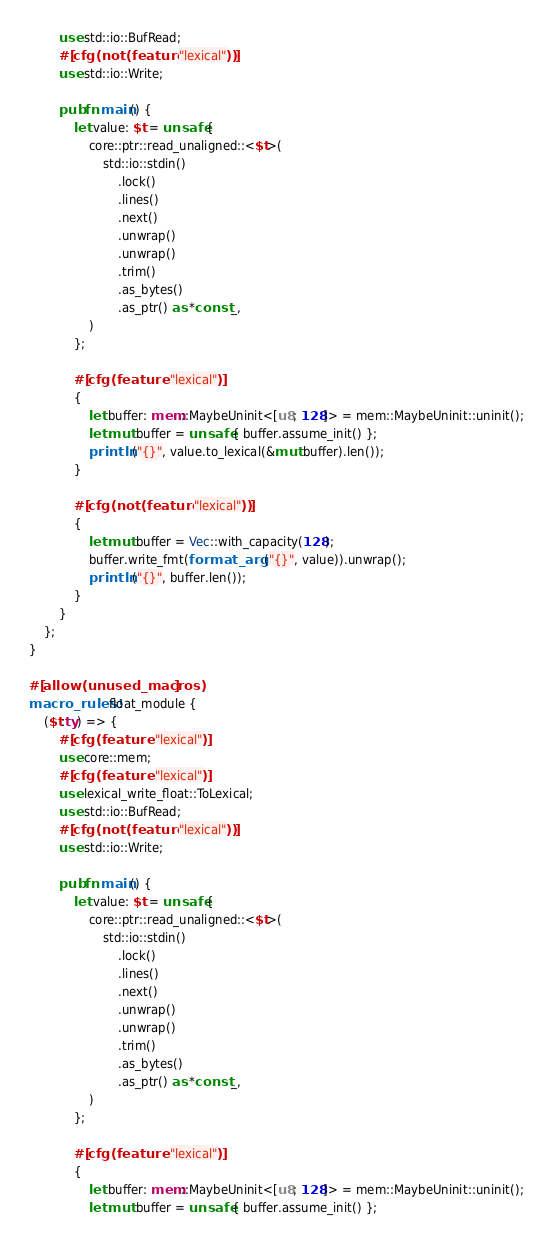Convert code to text. <code><loc_0><loc_0><loc_500><loc_500><_Rust_>        use std::io::BufRead;
        #[cfg(not(feature = "lexical"))]
        use std::io::Write;

        pub fn main() {
            let value: $t = unsafe {
                core::ptr::read_unaligned::<$t>(
                    std::io::stdin()
                        .lock()
                        .lines()
                        .next()
                        .unwrap()
                        .unwrap()
                        .trim()
                        .as_bytes()
                        .as_ptr() as *const _,
                )
            };

            #[cfg(feature = "lexical")]
            {
                let buffer: mem::MaybeUninit<[u8; 128]> = mem::MaybeUninit::uninit();
                let mut buffer = unsafe { buffer.assume_init() };
                println!("{}", value.to_lexical(&mut buffer).len());
            }

            #[cfg(not(feature = "lexical"))]
            {
                let mut buffer = Vec::with_capacity(128);
                buffer.write_fmt(format_args!("{}", value)).unwrap();
                println!("{}", buffer.len());
            }
        }
    };
}

#[allow(unused_macros)]
macro_rules! float_module {
    ($t:ty) => {
        #[cfg(feature = "lexical")]
        use core::mem;
        #[cfg(feature = "lexical")]
        use lexical_write_float::ToLexical;
        use std::io::BufRead;
        #[cfg(not(feature = "lexical"))]
        use std::io::Write;

        pub fn main() {
            let value: $t = unsafe {
                core::ptr::read_unaligned::<$t>(
                    std::io::stdin()
                        .lock()
                        .lines()
                        .next()
                        .unwrap()
                        .unwrap()
                        .trim()
                        .as_bytes()
                        .as_ptr() as *const _,
                )
            };

            #[cfg(feature = "lexical")]
            {
                let buffer: mem::MaybeUninit<[u8; 128]> = mem::MaybeUninit::uninit();
                let mut buffer = unsafe { buffer.assume_init() };</code> 